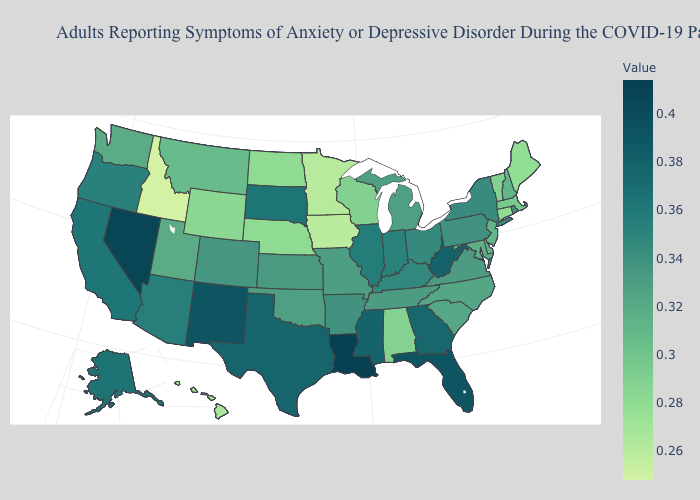Does Nevada have the highest value in the West?
Concise answer only. Yes. Does Louisiana have the highest value in the USA?
Write a very short answer. Yes. Which states have the highest value in the USA?
Give a very brief answer. Louisiana. Does the map have missing data?
Write a very short answer. No. Which states hav the highest value in the South?
Give a very brief answer. Louisiana. Does Louisiana have the highest value in the USA?
Be succinct. Yes. Among the states that border Alabama , which have the lowest value?
Be succinct. Tennessee. Among the states that border Nevada , which have the highest value?
Short answer required. California. Does Kentucky have a higher value than Alaska?
Keep it brief. No. 